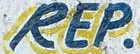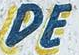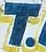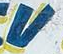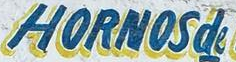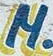What words are shown in these images in order, separated by a semicolon? REP; DE; T; V; HORNOSde; M 